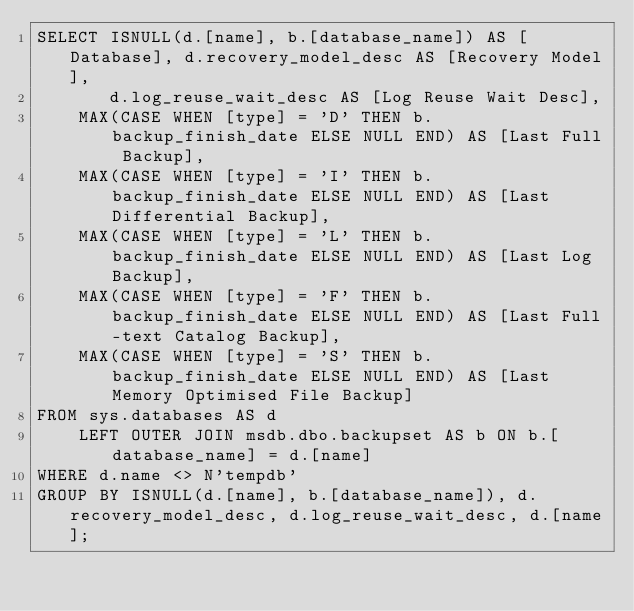<code> <loc_0><loc_0><loc_500><loc_500><_SQL_>SELECT ISNULL(d.[name], b.[database_name]) AS [Database], d.recovery_model_desc AS [Recovery Model], 
       d.log_reuse_wait_desc AS [Log Reuse Wait Desc],
    MAX(CASE WHEN [type] = 'D' THEN b.backup_finish_date ELSE NULL END) AS [Last Full Backup],
    MAX(CASE WHEN [type] = 'I' THEN b.backup_finish_date ELSE NULL END) AS [Last Differential Backup],
    MAX(CASE WHEN [type] = 'L' THEN b.backup_finish_date ELSE NULL END) AS [Last Log Backup],
	MAX(CASE WHEN [type] = 'F' THEN b.backup_finish_date ELSE NULL END) AS [Last Full-text Catalog Backup],
	MAX(CASE WHEN [type] = 'S' THEN b.backup_finish_date ELSE NULL END) AS [Last Memory Optimised File Backup]
FROM sys.databases AS d
	LEFT OUTER JOIN msdb.dbo.backupset AS b ON b.[database_name] = d.[name]
WHERE d.name <> N'tempdb' 
GROUP BY ISNULL(d.[name], b.[database_name]), d.recovery_model_desc, d.log_reuse_wait_desc, d.[name];
</code> 